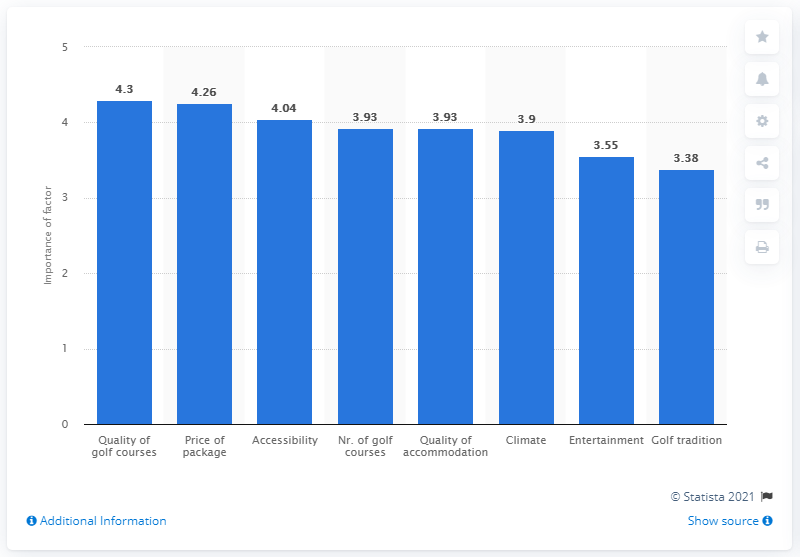Identify some key points in this picture. The factor quality of golf courses has a score of 4.3. 